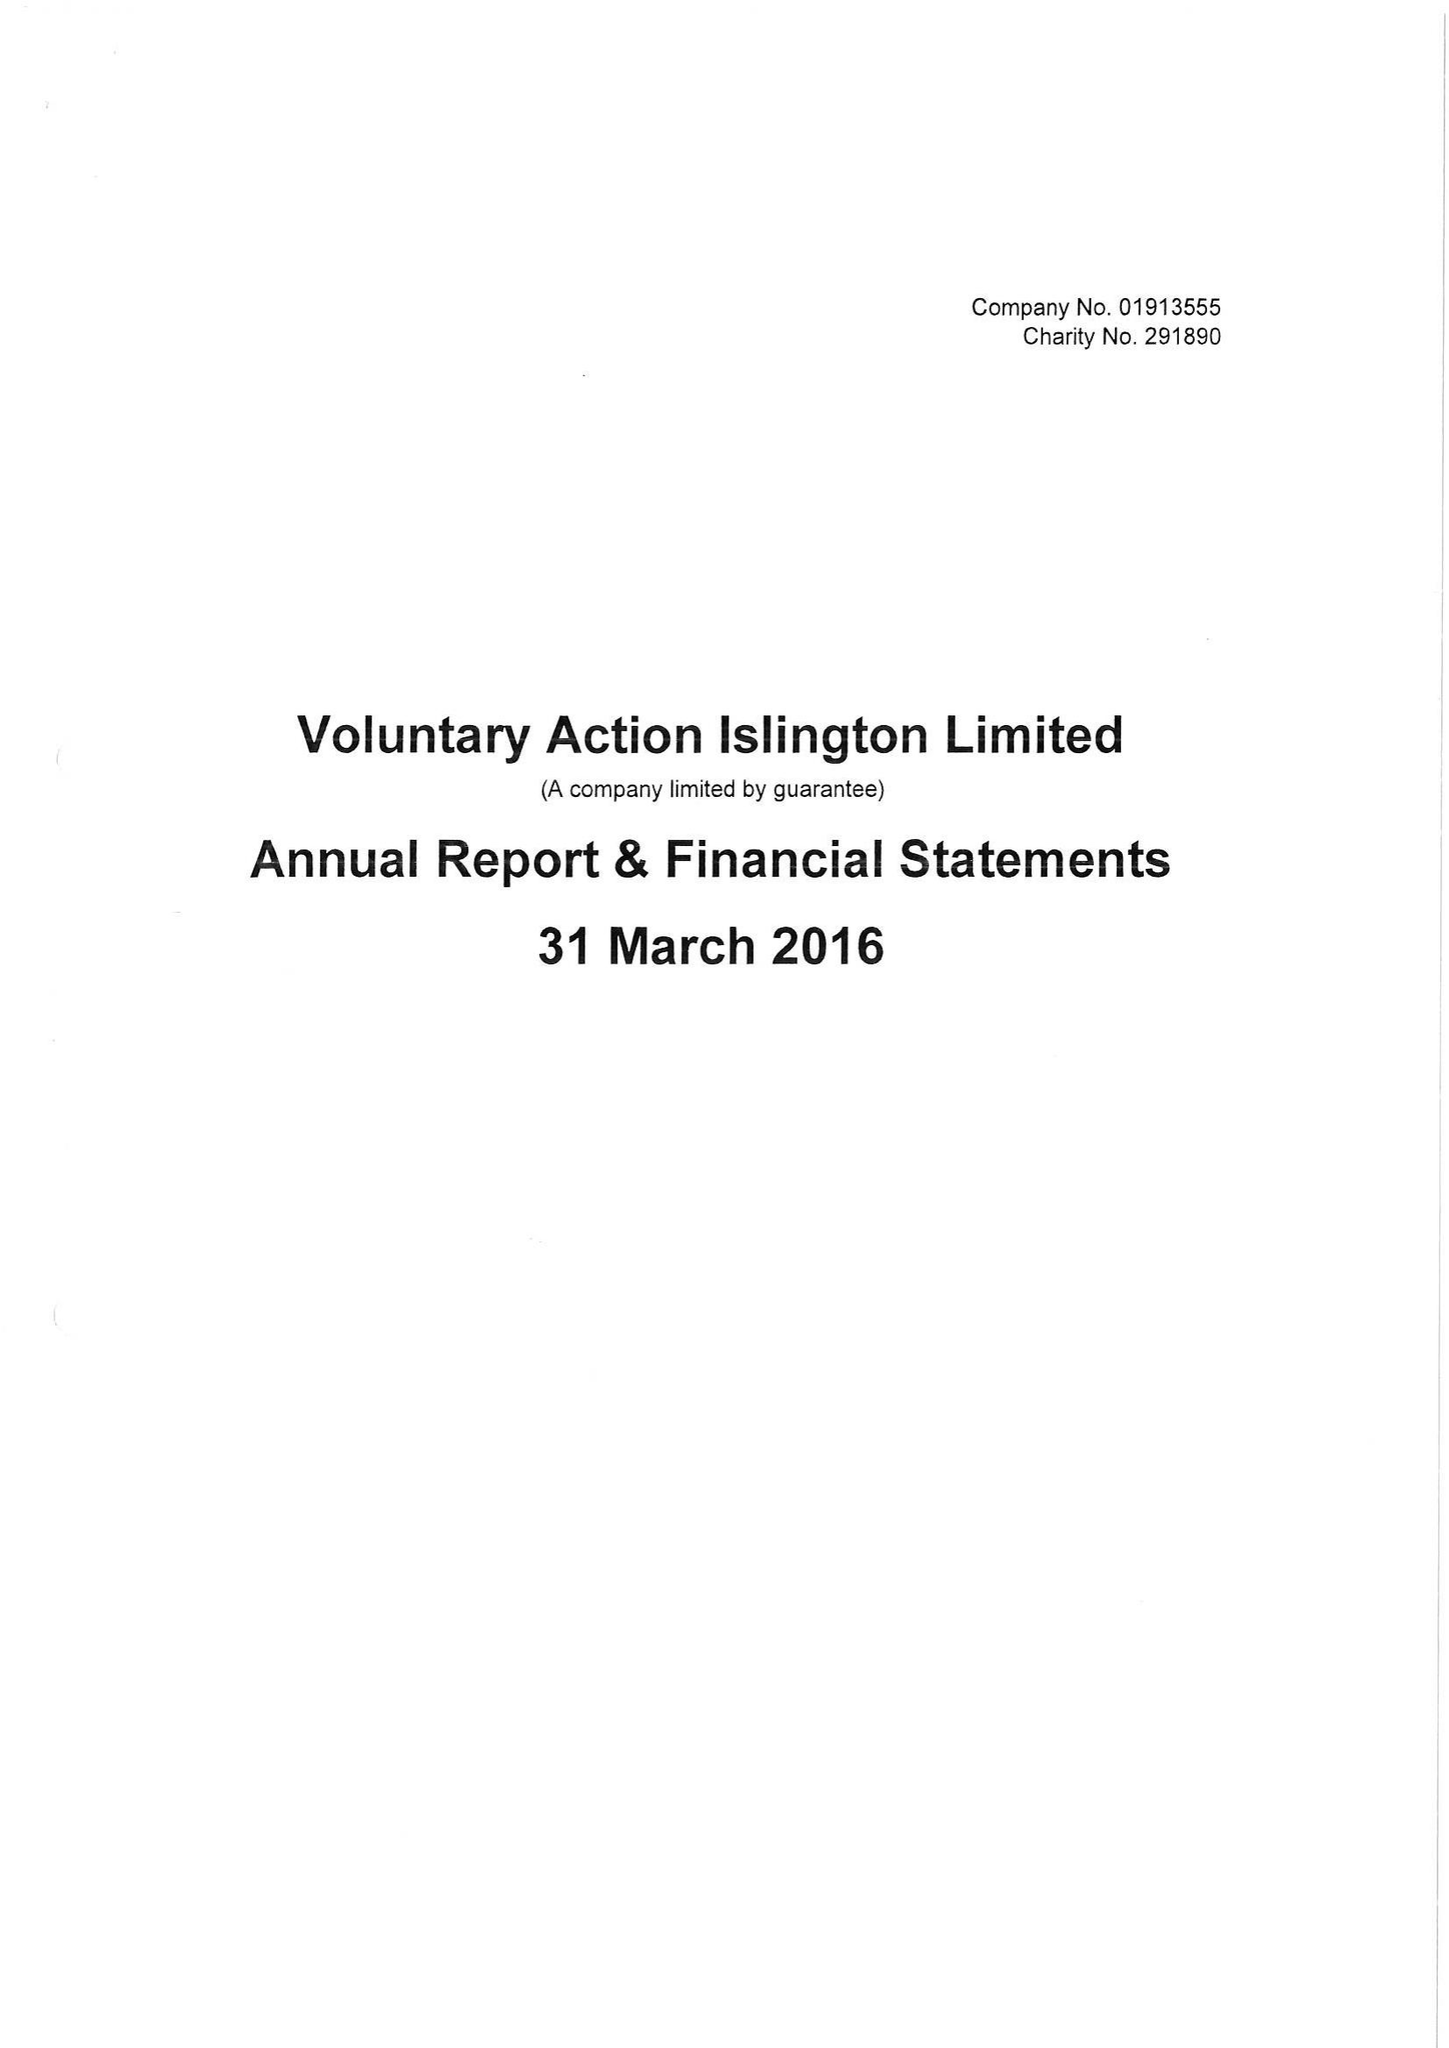What is the value for the address__post_town?
Answer the question using a single word or phrase. LONDON 